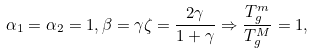Convert formula to latex. <formula><loc_0><loc_0><loc_500><loc_500>\alpha _ { 1 } = \alpha _ { 2 } = 1 , \beta = \gamma \zeta = \frac { 2 \gamma } { 1 + \gamma } \Rightarrow \frac { T _ { g } ^ { m } } { T _ { g } ^ { M } } = 1 ,</formula> 